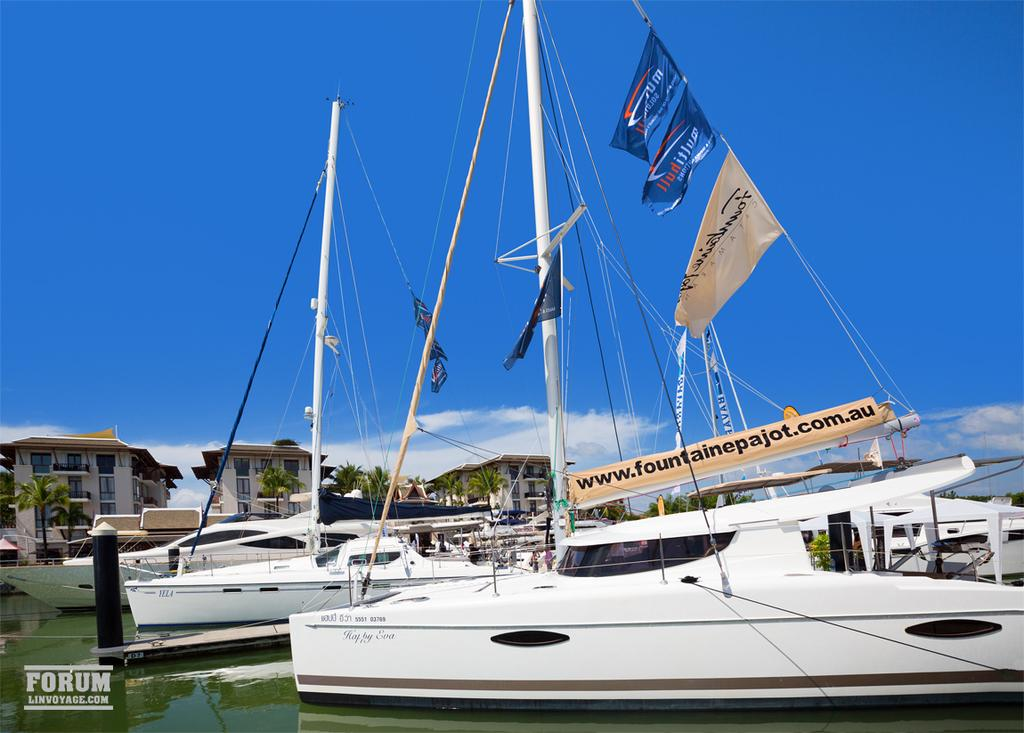What is on the water in the image? There are boats on the water in the image. What can be seen in the background of the image? There are trees and buildings in the background of the image. What is visible in the sky in the image? There are clouds in the sky, and the sky is blue. Where is the dog located in the image? There is no dog present in the image. What type of door can be seen on the boats in the image? There are no doors on the boats in the image, as boats typically do not have doors. 